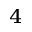<formula> <loc_0><loc_0><loc_500><loc_500>_ { 4 }</formula> 